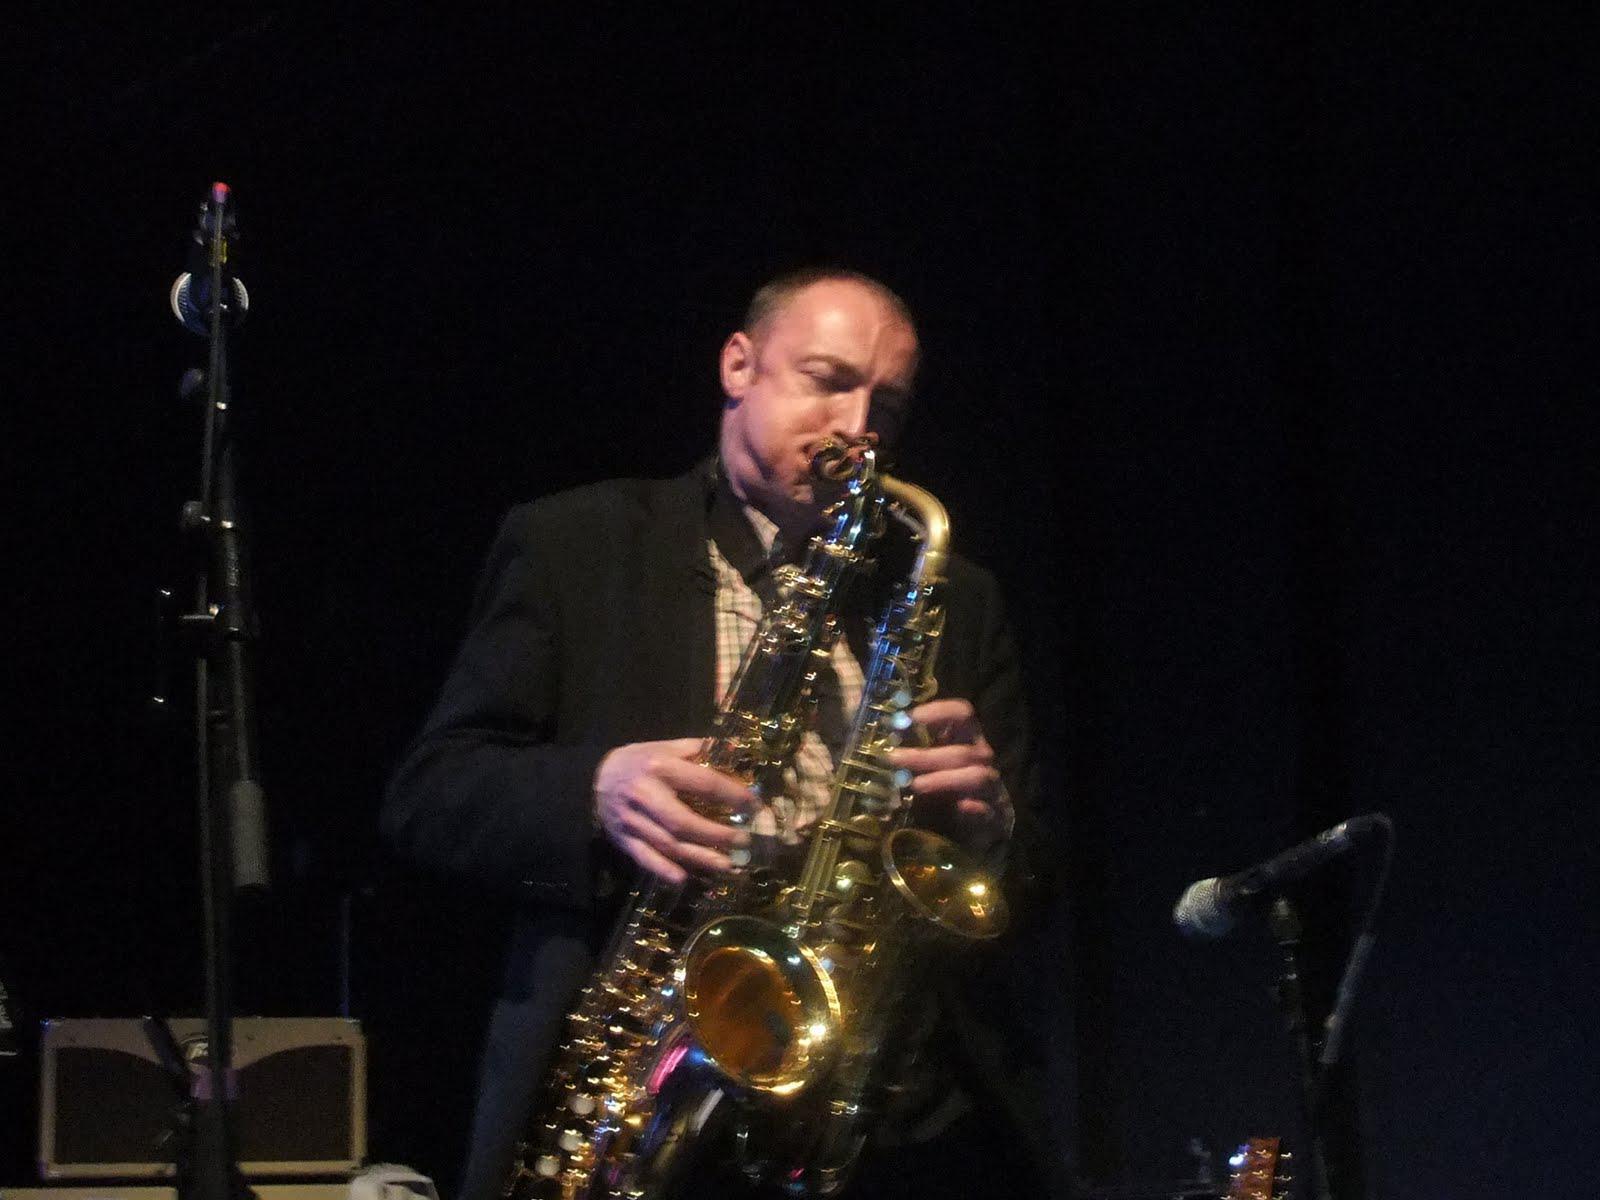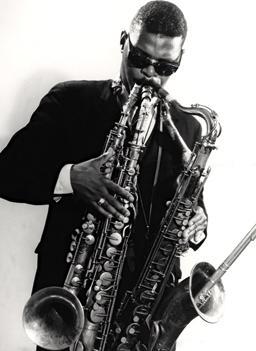The first image is the image on the left, the second image is the image on the right. Considering the images on both sides, is "The right image contains a man in dark sunglasses holding two saxophones." valid? Answer yes or no. Yes. The first image is the image on the left, the second image is the image on the right. Assess this claim about the two images: "Two men, each playing at least two saxophones simultaneously, are the sole people playing musical instruments in the images.". Correct or not? Answer yes or no. Yes. 